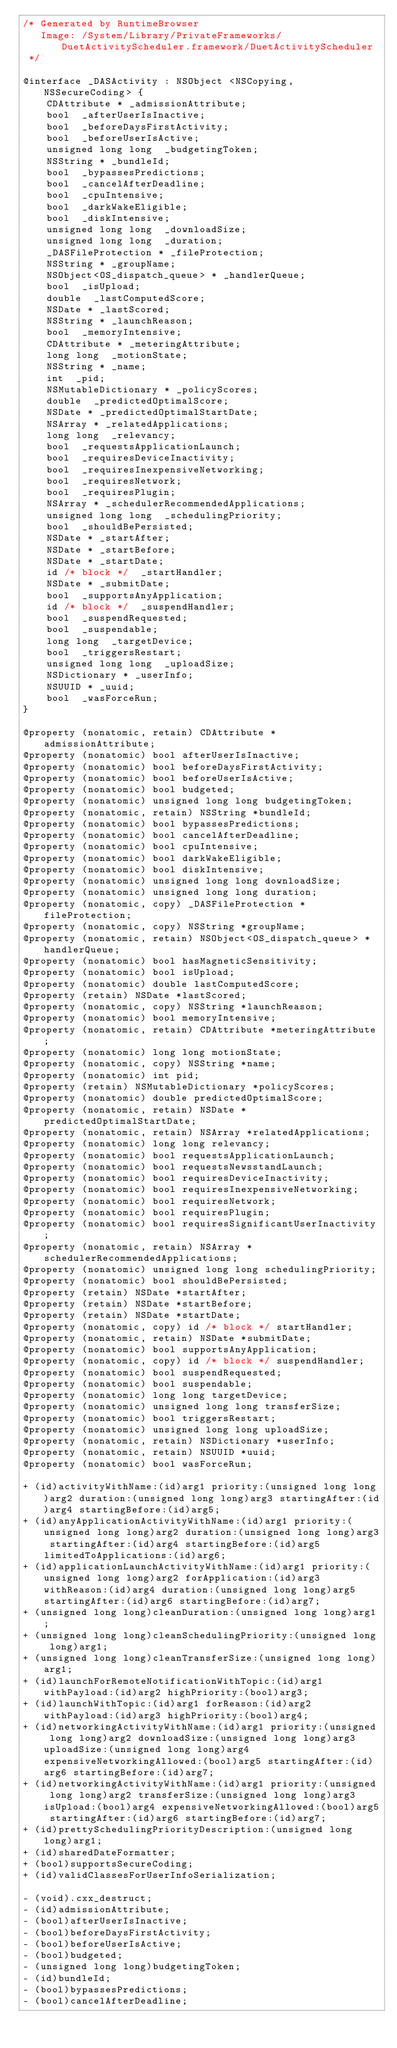Convert code to text. <code><loc_0><loc_0><loc_500><loc_500><_C_>/* Generated by RuntimeBrowser
   Image: /System/Library/PrivateFrameworks/DuetActivityScheduler.framework/DuetActivityScheduler
 */

@interface _DASActivity : NSObject <NSCopying, NSSecureCoding> {
    CDAttribute * _admissionAttribute;
    bool  _afterUserIsInactive;
    bool  _beforeDaysFirstActivity;
    bool  _beforeUserIsActive;
    unsigned long long  _budgetingToken;
    NSString * _bundleId;
    bool  _bypassesPredictions;
    bool  _cancelAfterDeadline;
    bool  _cpuIntensive;
    bool  _darkWakeEligible;
    bool  _diskIntensive;
    unsigned long long  _downloadSize;
    unsigned long long  _duration;
    _DASFileProtection * _fileProtection;
    NSString * _groupName;
    NSObject<OS_dispatch_queue> * _handlerQueue;
    bool  _isUpload;
    double  _lastComputedScore;
    NSDate * _lastScored;
    NSString * _launchReason;
    bool  _memoryIntensive;
    CDAttribute * _meteringAttribute;
    long long  _motionState;
    NSString * _name;
    int  _pid;
    NSMutableDictionary * _policyScores;
    double  _predictedOptimalScore;
    NSDate * _predictedOptimalStartDate;
    NSArray * _relatedApplications;
    long long  _relevancy;
    bool  _requestsApplicationLaunch;
    bool  _requiresDeviceInactivity;
    bool  _requiresInexpensiveNetworking;
    bool  _requiresNetwork;
    bool  _requiresPlugin;
    NSArray * _schedulerRecommendedApplications;
    unsigned long long  _schedulingPriority;
    bool  _shouldBePersisted;
    NSDate * _startAfter;
    NSDate * _startBefore;
    NSDate * _startDate;
    id /* block */  _startHandler;
    NSDate * _submitDate;
    bool  _supportsAnyApplication;
    id /* block */  _suspendHandler;
    bool  _suspendRequested;
    bool  _suspendable;
    long long  _targetDevice;
    bool  _triggersRestart;
    unsigned long long  _uploadSize;
    NSDictionary * _userInfo;
    NSUUID * _uuid;
    bool  _wasForceRun;
}

@property (nonatomic, retain) CDAttribute *admissionAttribute;
@property (nonatomic) bool afterUserIsInactive;
@property (nonatomic) bool beforeDaysFirstActivity;
@property (nonatomic) bool beforeUserIsActive;
@property (nonatomic) bool budgeted;
@property (nonatomic) unsigned long long budgetingToken;
@property (nonatomic, retain) NSString *bundleId;
@property (nonatomic) bool bypassesPredictions;
@property (nonatomic) bool cancelAfterDeadline;
@property (nonatomic) bool cpuIntensive;
@property (nonatomic) bool darkWakeEligible;
@property (nonatomic) bool diskIntensive;
@property (nonatomic) unsigned long long downloadSize;
@property (nonatomic) unsigned long long duration;
@property (nonatomic, copy) _DASFileProtection *fileProtection;
@property (nonatomic, copy) NSString *groupName;
@property (nonatomic, retain) NSObject<OS_dispatch_queue> *handlerQueue;
@property (nonatomic) bool hasMagneticSensitivity;
@property (nonatomic) bool isUpload;
@property (nonatomic) double lastComputedScore;
@property (retain) NSDate *lastScored;
@property (nonatomic, copy) NSString *launchReason;
@property (nonatomic) bool memoryIntensive;
@property (nonatomic, retain) CDAttribute *meteringAttribute;
@property (nonatomic) long long motionState;
@property (nonatomic, copy) NSString *name;
@property (nonatomic) int pid;
@property (retain) NSMutableDictionary *policyScores;
@property (nonatomic) double predictedOptimalScore;
@property (nonatomic, retain) NSDate *predictedOptimalStartDate;
@property (nonatomic, retain) NSArray *relatedApplications;
@property (nonatomic) long long relevancy;
@property (nonatomic) bool requestsApplicationLaunch;
@property (nonatomic) bool requestsNewsstandLaunch;
@property (nonatomic) bool requiresDeviceInactivity;
@property (nonatomic) bool requiresInexpensiveNetworking;
@property (nonatomic) bool requiresNetwork;
@property (nonatomic) bool requiresPlugin;
@property (nonatomic) bool requiresSignificantUserInactivity;
@property (nonatomic, retain) NSArray *schedulerRecommendedApplications;
@property (nonatomic) unsigned long long schedulingPriority;
@property (nonatomic) bool shouldBePersisted;
@property (retain) NSDate *startAfter;
@property (retain) NSDate *startBefore;
@property (retain) NSDate *startDate;
@property (nonatomic, copy) id /* block */ startHandler;
@property (nonatomic, retain) NSDate *submitDate;
@property (nonatomic) bool supportsAnyApplication;
@property (nonatomic, copy) id /* block */ suspendHandler;
@property (nonatomic) bool suspendRequested;
@property (nonatomic) bool suspendable;
@property (nonatomic) long long targetDevice;
@property (nonatomic) unsigned long long transferSize;
@property (nonatomic) bool triggersRestart;
@property (nonatomic) unsigned long long uploadSize;
@property (nonatomic, retain) NSDictionary *userInfo;
@property (nonatomic, retain) NSUUID *uuid;
@property (nonatomic) bool wasForceRun;

+ (id)activityWithName:(id)arg1 priority:(unsigned long long)arg2 duration:(unsigned long long)arg3 startingAfter:(id)arg4 startingBefore:(id)arg5;
+ (id)anyApplicationActivityWithName:(id)arg1 priority:(unsigned long long)arg2 duration:(unsigned long long)arg3 startingAfter:(id)arg4 startingBefore:(id)arg5 limitedToApplications:(id)arg6;
+ (id)applicationLaunchActivityWithName:(id)arg1 priority:(unsigned long long)arg2 forApplication:(id)arg3 withReason:(id)arg4 duration:(unsigned long long)arg5 startingAfter:(id)arg6 startingBefore:(id)arg7;
+ (unsigned long long)cleanDuration:(unsigned long long)arg1;
+ (unsigned long long)cleanSchedulingPriority:(unsigned long long)arg1;
+ (unsigned long long)cleanTransferSize:(unsigned long long)arg1;
+ (id)launchForRemoteNotificationWithTopic:(id)arg1 withPayload:(id)arg2 highPriority:(bool)arg3;
+ (id)launchWithTopic:(id)arg1 forReason:(id)arg2 withPayload:(id)arg3 highPriority:(bool)arg4;
+ (id)networkingActivityWithName:(id)arg1 priority:(unsigned long long)arg2 downloadSize:(unsigned long long)arg3 uploadSize:(unsigned long long)arg4 expensiveNetworkingAllowed:(bool)arg5 startingAfter:(id)arg6 startingBefore:(id)arg7;
+ (id)networkingActivityWithName:(id)arg1 priority:(unsigned long long)arg2 transferSize:(unsigned long long)arg3 isUpload:(bool)arg4 expensiveNetworkingAllowed:(bool)arg5 startingAfter:(id)arg6 startingBefore:(id)arg7;
+ (id)prettySchedulingPriorityDescription:(unsigned long long)arg1;
+ (id)sharedDateFormatter;
+ (bool)supportsSecureCoding;
+ (id)validClassesForUserInfoSerialization;

- (void).cxx_destruct;
- (id)admissionAttribute;
- (bool)afterUserIsInactive;
- (bool)beforeDaysFirstActivity;
- (bool)beforeUserIsActive;
- (bool)budgeted;
- (unsigned long long)budgetingToken;
- (id)bundleId;
- (bool)bypassesPredictions;
- (bool)cancelAfterDeadline;</code> 